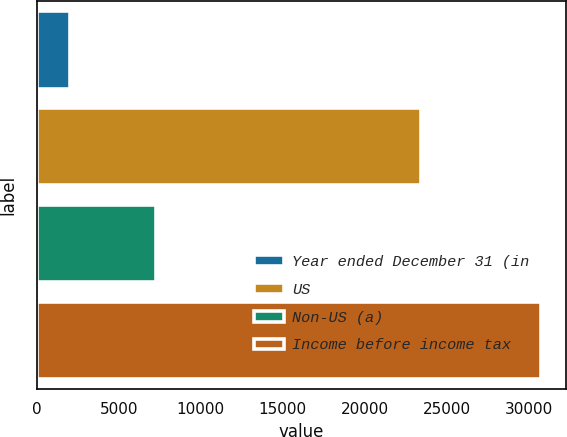Convert chart to OTSL. <chart><loc_0><loc_0><loc_500><loc_500><bar_chart><fcel>Year ended December 31 (in<fcel>US<fcel>Non-US (a)<fcel>Income before income tax<nl><fcel>2014<fcel>23422<fcel>7277<fcel>30699<nl></chart> 